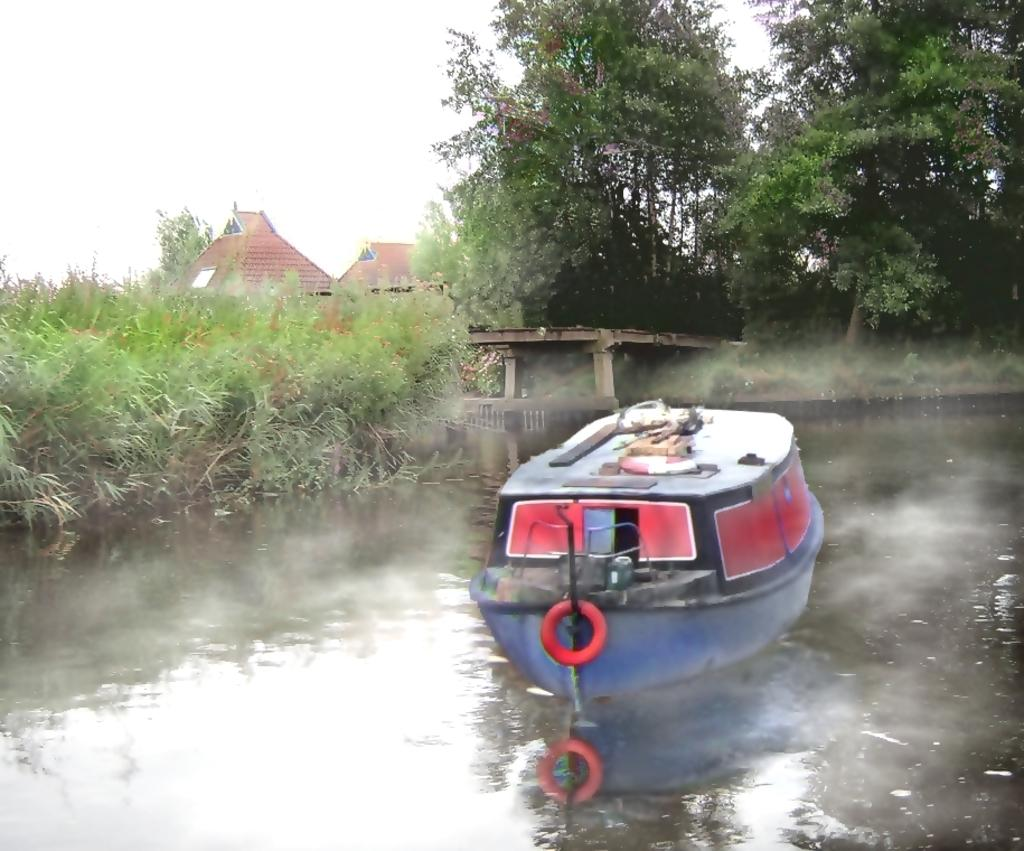What is the main subject of the image? The main subject of the image is a boat. Where is the boat located? The boat is on the water. What type of vegetation can be seen in the image? There are plants and trees visible in the image. What is in the background of the image? There is a building in the background of the image. What is visible at the top of the image? The sky is visible at the top of the image. Can you tell me how many women are blowing bubbles in the image? There are no women or bubbles present in the image. What type of tool is being used to dig in the image? There is no tool being used to dig in the image. 